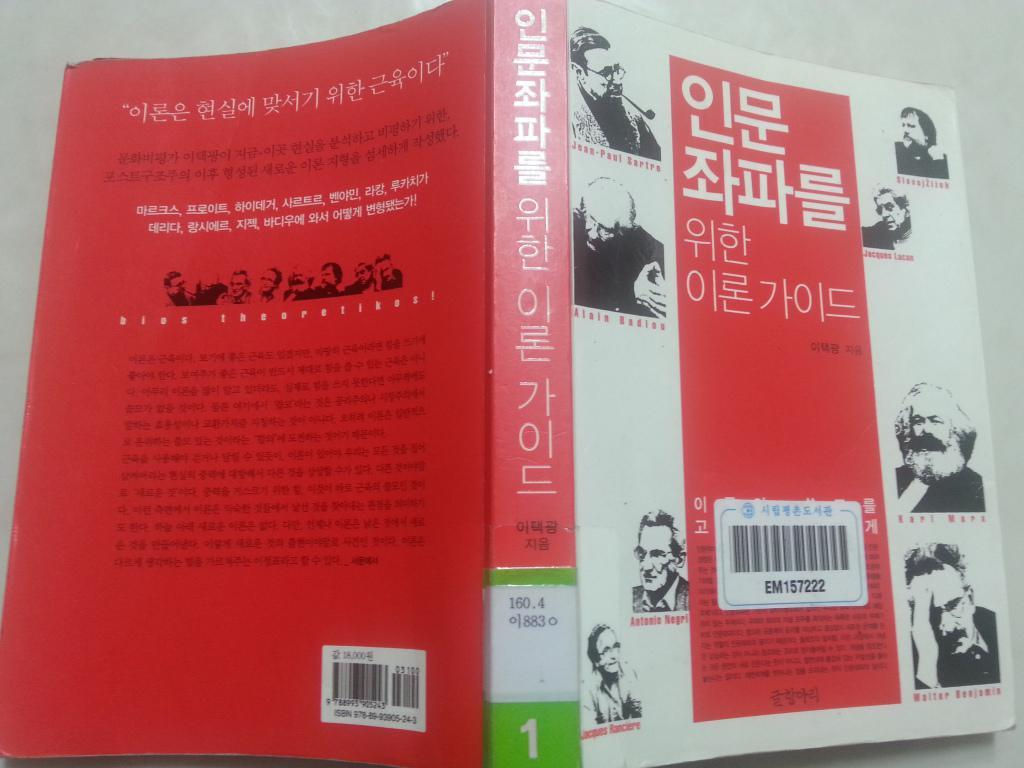<image>
Summarize the visual content of the image. Korean language book with the bar code EM157222 on the cover. 